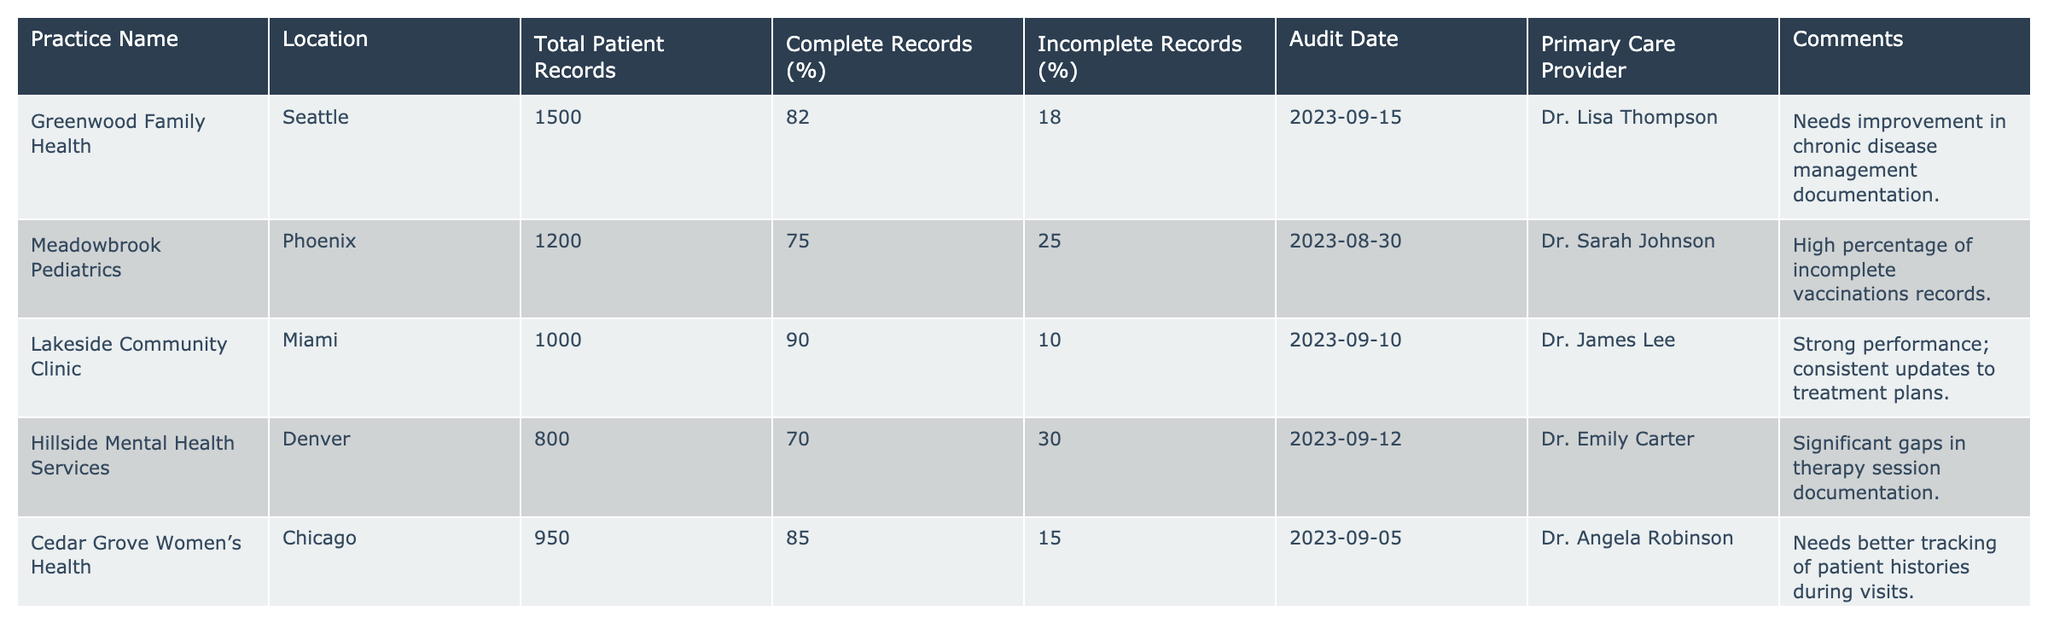What is the practice with the highest percentage of complete records? By reviewing the 'Complete Records (%)' column, I see that Lakeside Community Clinic has the highest percentage at 90%.
Answer: Lakeside Community Clinic How many total patient records does Meadowbrook Pediatrics have? Looking at the 'Total Patient Records' column, Meadowbrook Pediatrics has 1200 patient records.
Answer: 1200 What is the average percentage of complete records across all practices? Adding the complete record percentages (82 + 75 + 90 + 70 + 85 + 78 + 80 + 72 + 65 =  72.78) gives a total of 72.78. Dividing by the number of practices (9) results in an average of approximately 77.55%.
Answer: 77.55% Which practice has the largest number of incomplete records in terms of percentage? By comparing the 'Incomplete Records (%)' column, Mountainview Behavioral Health has the highest percentage of incomplete records at 35%.
Answer: Mountainview Behavioral Health Is the primary care provider for Riverside Geriatric Care Dr. Michael Brown? Checking the 'Primary Care Provider' column for Riverside Geriatric Care confirms that Dr. Michael Brown is indeed the provider.
Answer: Yes How many practices have complete records below 80%? Analyzing the 'Complete Records (%)' column, I find that Hillside Mental Health Services (70%), Meadowbrook Pediatrics (75%), and Mountainview Behavioral Health (65%) all have percentages below 80%, totaling 3 practices.
Answer: 3 Which practice needs improvement in chronic disease management documentation? The comments section notes that Greenwood Family Health requires improvement in chronic disease management documentation.
Answer: Greenwood Family Health What percentage of incomplete records does Oakhill Family Medicine have? Referring to the 'Incomplete Records (%)' column for Oakhill Family Medicine reveals that it has 20% incomplete records.
Answer: 20% Which two practices have a total patient record count of more than 1,500? From the 'Total Patient Records' column, Oakhill Family Medicine (1700) and Greenwood Family Health (1500) both exceed 1,500.
Answer: Oakhill Family Medicine and Greenwood Family Health What are the locations of the practices with complete records above 80%? Identifying practices with complete records above 80% leads to Lakeside Community Clinic (Miami), Cedar Grove Women’s Health (Chicago), and Greenwood Family Health (Seattle), located in their respective cities.
Answer: Miami, Chicago, Seattle 